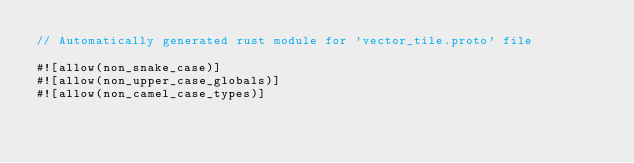<code> <loc_0><loc_0><loc_500><loc_500><_Rust_>// Automatically generated rust module for 'vector_tile.proto' file

#![allow(non_snake_case)]
#![allow(non_upper_case_globals)]
#![allow(non_camel_case_types)]</code> 